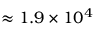Convert formula to latex. <formula><loc_0><loc_0><loc_500><loc_500>\approx 1 . 9 \times 1 0 ^ { 4 }</formula> 